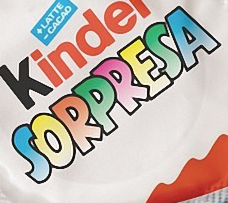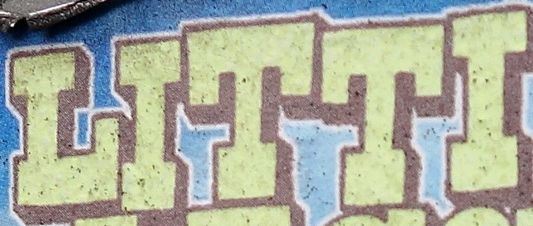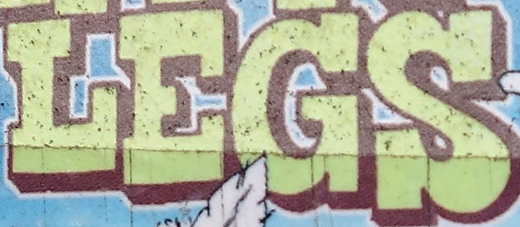What text is displayed in these images sequentially, separated by a semicolon? SORPRESA; LITTI; LEGS 